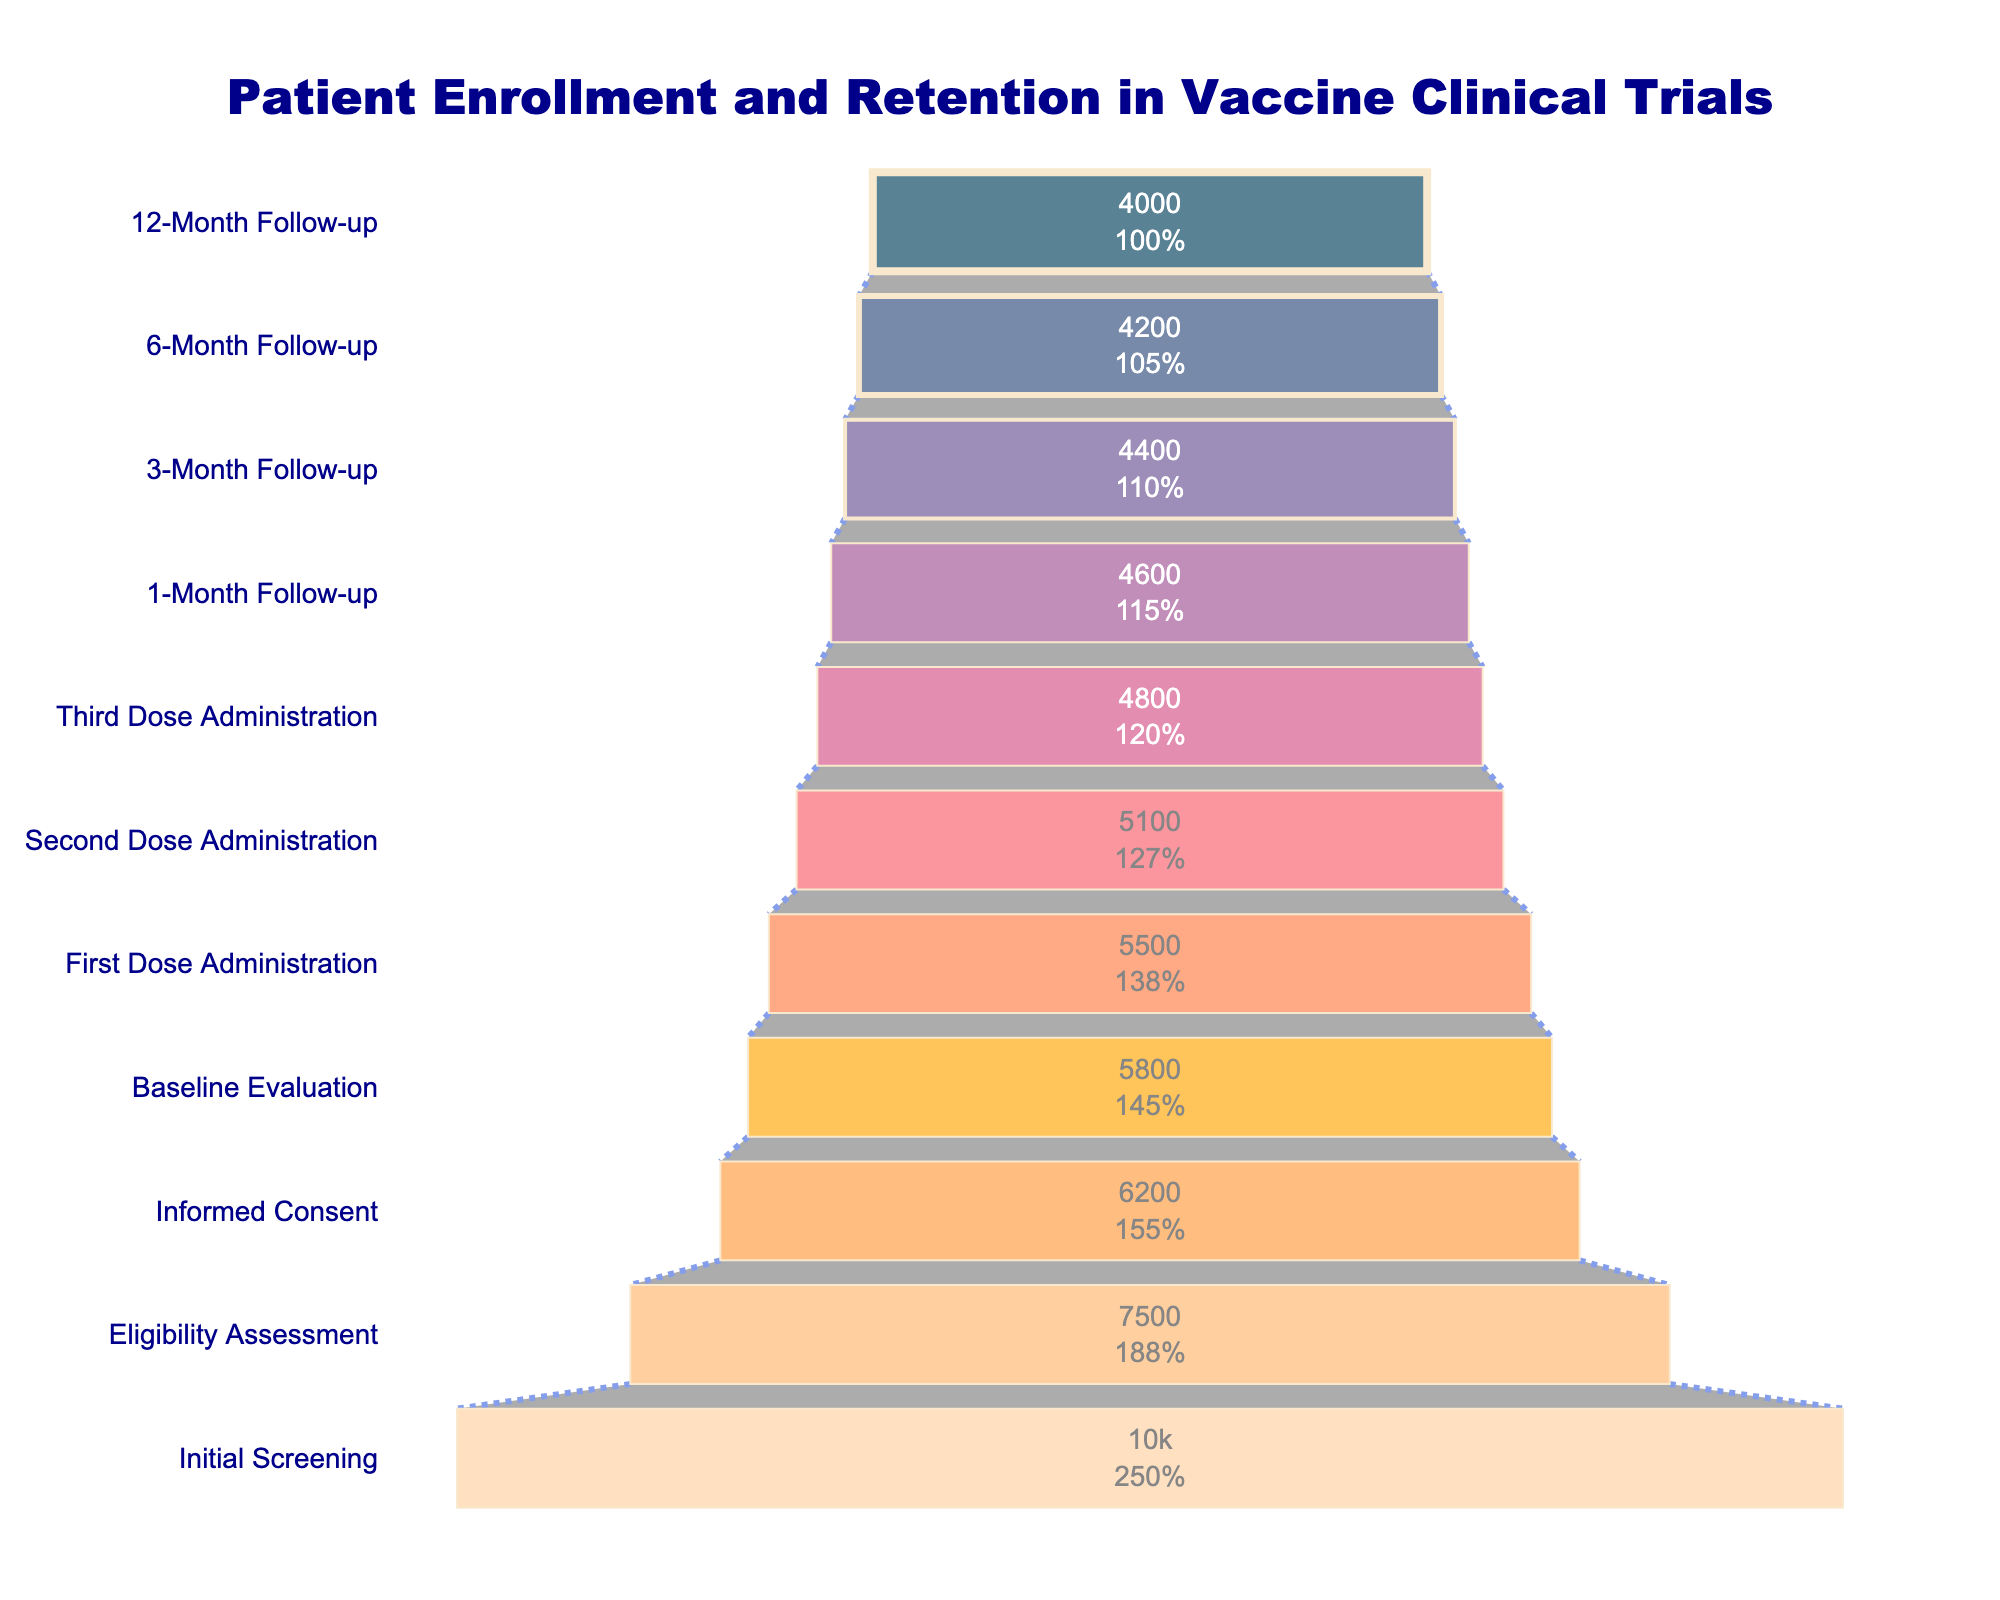What's the title of the chart? The title is found at the top of the chart. It reads "Patient Enrollment and Retention in Vaccine Clinical Trials."
Answer: Patient Enrollment and Retention in Vaccine Clinical Trials How many participants were left at the 3-Month Follow-up stage? Look for the "3-Month Follow-up" label on the y-axis, then read the corresponding x-axis value. This value is 4400 participants.
Answer: 4400 What is the percentage of participants who followed through from Initial Screening to 12-Month Follow-up? Divide the number of participants at the 12-Month Follow-up stage (4000) by the number of participants at the Initial Screening stage (10000), then multiply by 100% to get the retention rate. 4000 / 10000 * 100 = 40%.
Answer: 40% Which stage experiences the largest drop in participant numbers? Compare the differences in participant numbers between each consecutive stage. The largest difference is between Initial Screening (10000) and Eligibility Assessment (7500), a drop of 2500 participants.
Answer: Initial Screening to Eligibility Assessment By how many participants do the numbers decrease from the First Dose Administration to the Second Dose Administration? Subtract the number of participants at the Second Dose Administration (5100) from the number at the First Dose Administration (5500). 5500 - 5100 = 400.
Answer: 400 What is the retention rate from Baseline Evaluation to 1-Month Follow-up? Divide the number of participants at the 1-Month Follow-up (4600) by the number at Baseline Evaluation (5800), then multiply by 100%. 4600 / 5800 * 100 ≈ 79.31%.
Answer: ~79.31% Describe the color scheme used in the funnel chart. The chart uses a gradient color scheme that transitions from dark blue at the top to a lighter orange at the bottom.
Answer: Dark blue to light orange Which two stages have exactly 200 fewer participants than their previous stage? Review the participant numbers for each stage and find pairs with a difference of 200. The stages are 3-Month Follow-up (4400) and 6-Month Follow-up (4200), and 6-Month Follow-up (4200) and 12-Month Follow-up (4000).
Answer: 3-Month Follow-up to 6-Month Follow-up, 6-Month Follow-up to 12-Month Follow-up What is the connector line style used in the funnel chart? The connector lines between stages are styled with a dotted, royal blue line, as indicated by the visual appearance in the chart.
Answer: Dotted, royal blue Identify the stage with the fewest participants remaining. Read the participant numbers from top to bottom; the stage with the lowest number is the last one listed, which is the 12-Month Follow-up with 4000 participants.
Answer: 12-Month Follow-up 